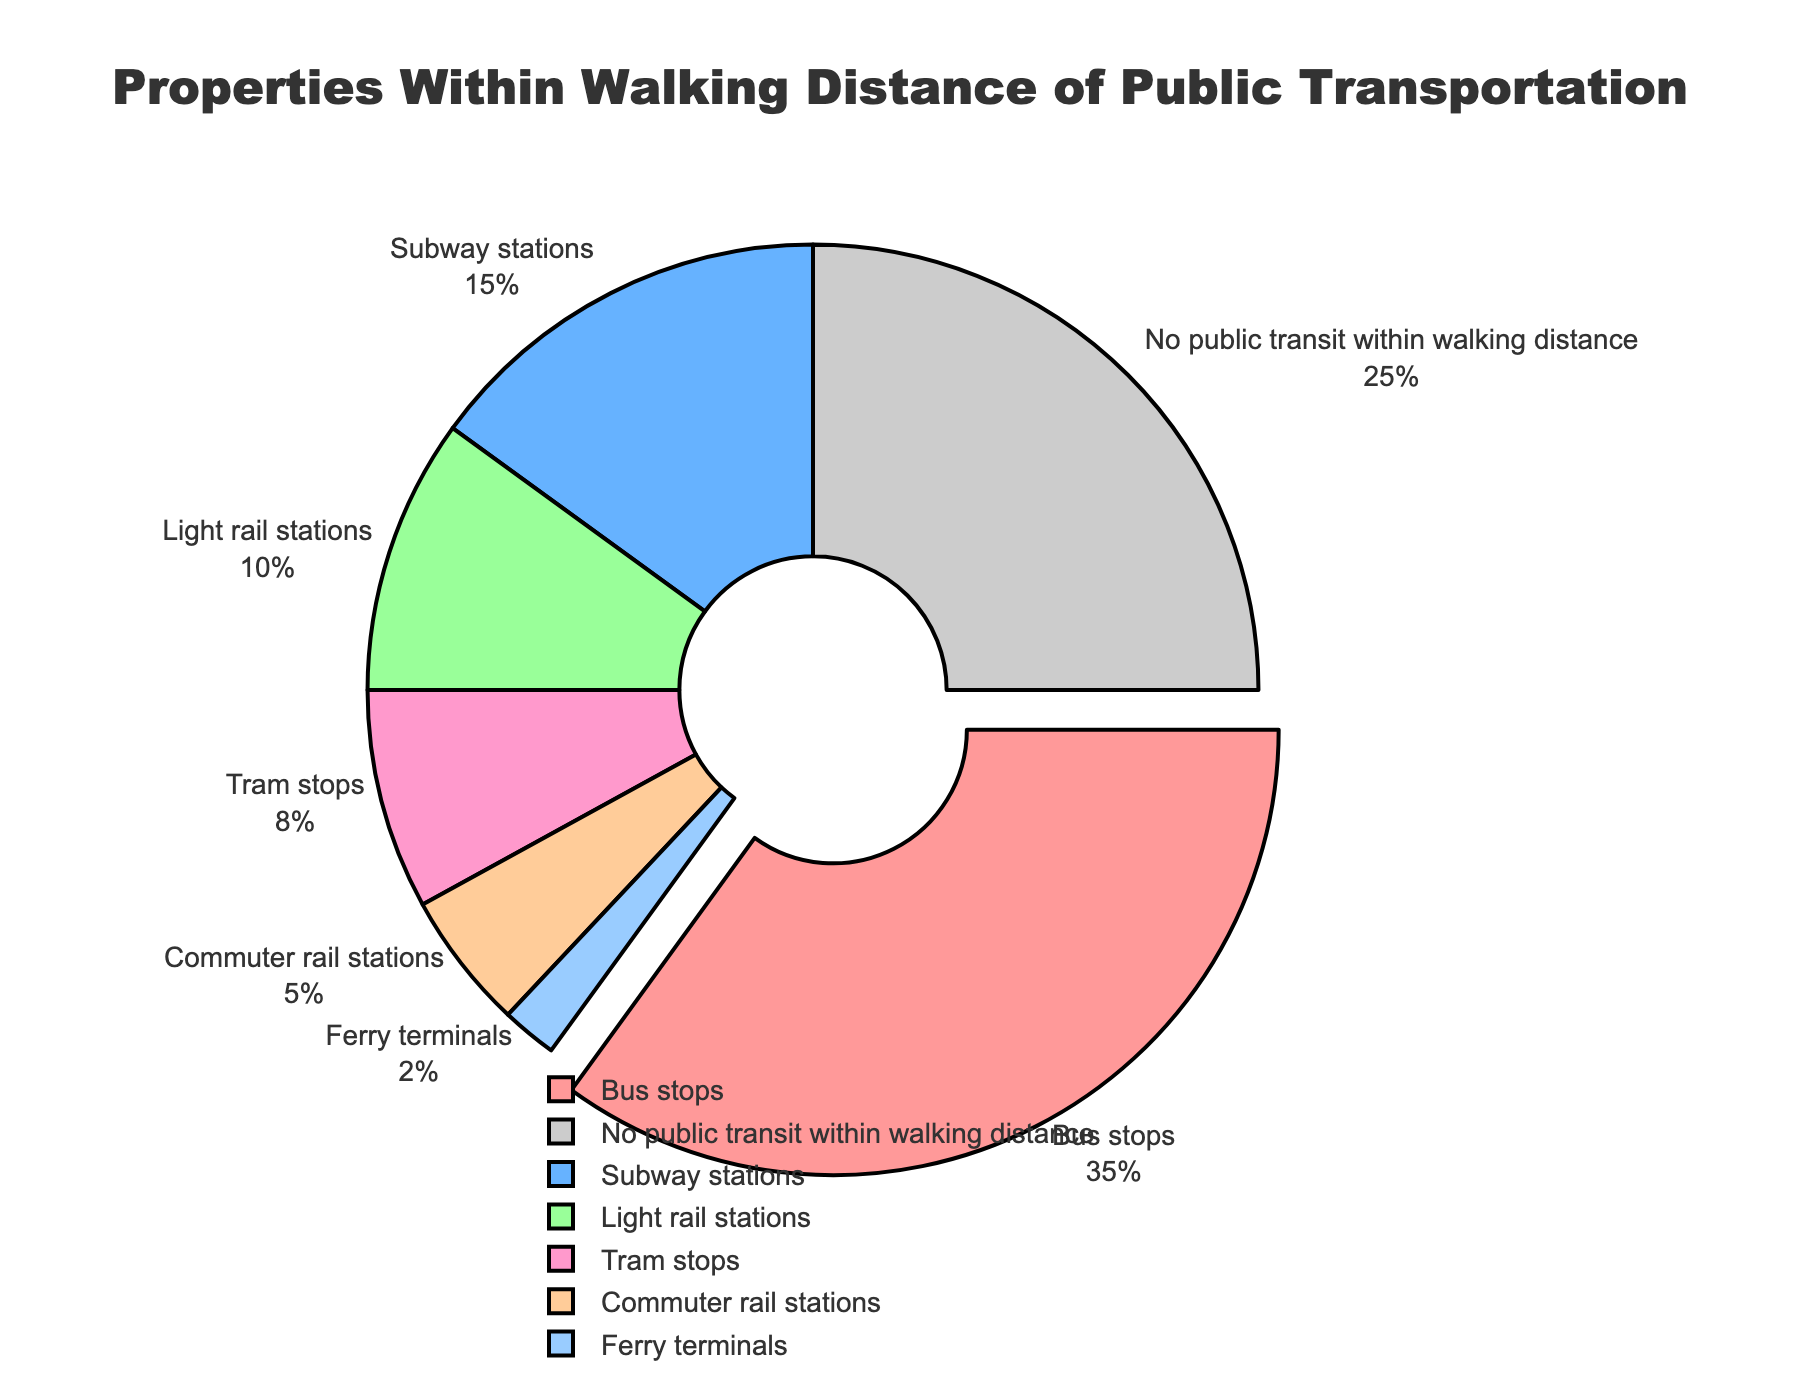Which category has the largest percentage of properties within walking distance? The largest percentage segment in the pie chart is labeled "Bus stops" and it occupies the biggest portion of the chart, highlighted by a slight pull effect.
Answer: Bus stops Which public transportation option has the smallest percentage of properties within walking distance? The smallest percentage segment in the pie chart is labeled "Ferry terminals." It's also the smallest visual section of the pie chart.
Answer: Ferry terminals What percentage of properties have no public transit within walking distance? This information is displayed directly on the pie chart and the segment for "No public transit within walking distance" occupies 25% of the chart.
Answer: 25% How does the percentage of properties within walking distance of subway stations compare to those near tram stops? Referring to the pie chart, subway stations have a segment labeled "15%" while tram stops have a segment labeled "8%". Since 15% is greater than 8%, subway stations have a higher percentage.
Answer: Subway stations have a higher percentage What is the combined percentage of properties within walking distance of commuter rail and light rail stations? Adding the percentages from the pie chart: 5% (commuter rail stations) + 10% (light rail stations) = 15%.
Answer: 15% If we exclude properties with no public transit within walking distance, what percentage of the remaining properties are near bus stops? First, calculate the total percentage excluding no public transit: 100% - 25% = 75%. Then, calculate the percentage of bus stops within this subset: (35% / 75%) * 100% = 46.67%.
Answer: 46.67% Which categories have percentages that total more than 50% when combined? Checking categories individually and summing them: 35% (bus stops) + 15% (subway stations) = 50%. Since 35% (bus stops) + 15% (subway stations) + remaining categories would exceed 50%, bus stops and subway stations alone reach 50%. Further adding more categories will exceed it.
Answer: Bus stops and Subway stations What is the difference in percentage between properties near bus stops and those near light rail stations? Subtract the percentage of light rail stations from bus stops: 35% (bus stops) - 10% (light rail stations) = 25%.
Answer: 25% What proportion of the properties are within walking distance of either tram stops or ferry terminals compared to the total properties? Combine the percentages of tram stops and ferry terminals: 8% (tram stops) + 2% (ferry terminals) = 10%.
Answer: 10% What is the total percentage of properties within walking distance of bus stops, subway stations, and light rail stations combined? Adding the percentages from these categories: 35% (bus stops) + 15% (subway stations) + 10% (light rail stations) = 60%.
Answer: 60% 